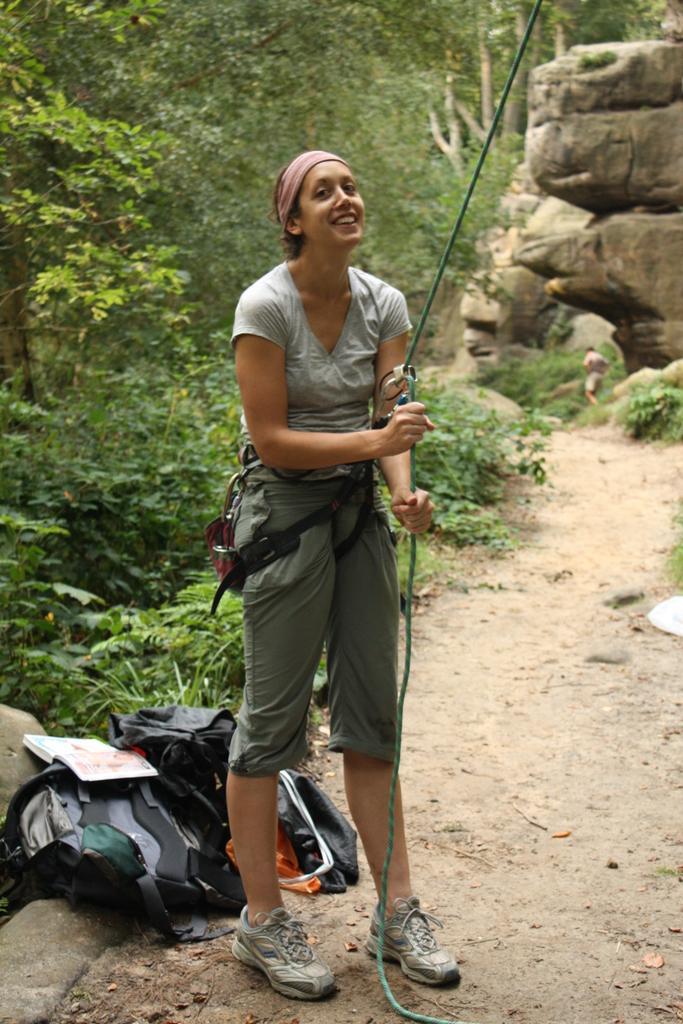How would you summarize this image in a sentence or two? In this image I can see a woman is holding the rope, she is wearing a t-shirt, short, shoes. At the bottom there are bags on the ground, on the left side there are trees, on the right side there are rocks. 